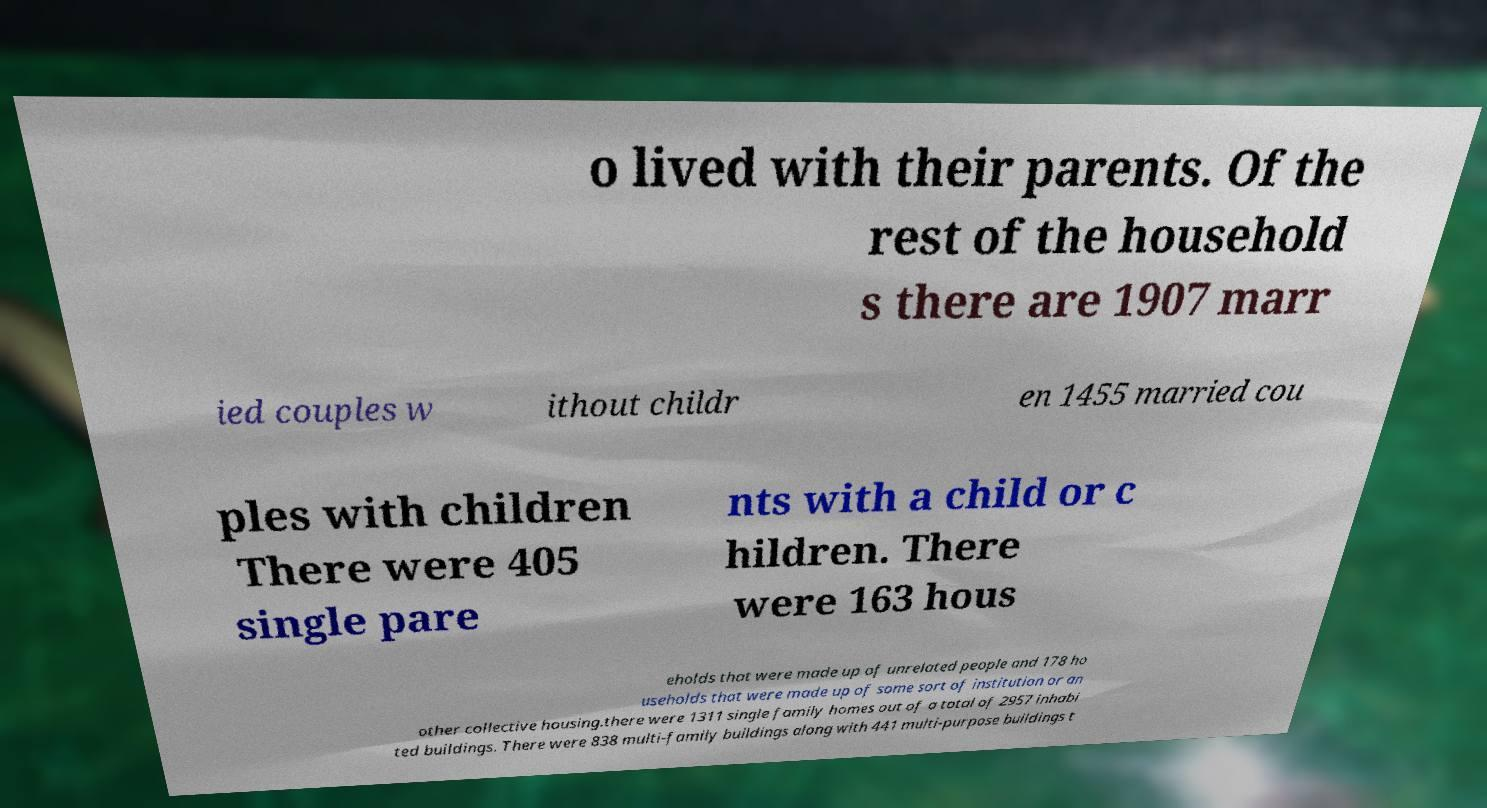Could you extract and type out the text from this image? o lived with their parents. Of the rest of the household s there are 1907 marr ied couples w ithout childr en 1455 married cou ples with children There were 405 single pare nts with a child or c hildren. There were 163 hous eholds that were made up of unrelated people and 178 ho useholds that were made up of some sort of institution or an other collective housing.there were 1311 single family homes out of a total of 2957 inhabi ted buildings. There were 838 multi-family buildings along with 441 multi-purpose buildings t 